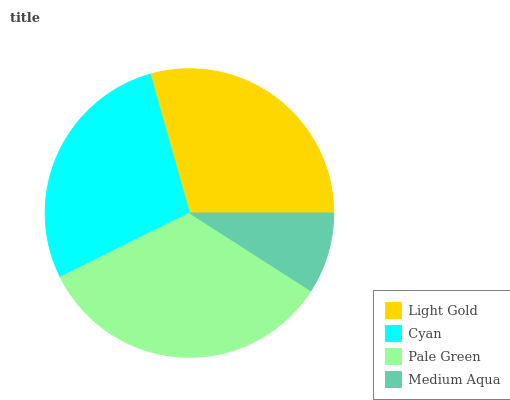Is Medium Aqua the minimum?
Answer yes or no. Yes. Is Pale Green the maximum?
Answer yes or no. Yes. Is Cyan the minimum?
Answer yes or no. No. Is Cyan the maximum?
Answer yes or no. No. Is Light Gold greater than Cyan?
Answer yes or no. Yes. Is Cyan less than Light Gold?
Answer yes or no. Yes. Is Cyan greater than Light Gold?
Answer yes or no. No. Is Light Gold less than Cyan?
Answer yes or no. No. Is Light Gold the high median?
Answer yes or no. Yes. Is Cyan the low median?
Answer yes or no. Yes. Is Cyan the high median?
Answer yes or no. No. Is Light Gold the low median?
Answer yes or no. No. 